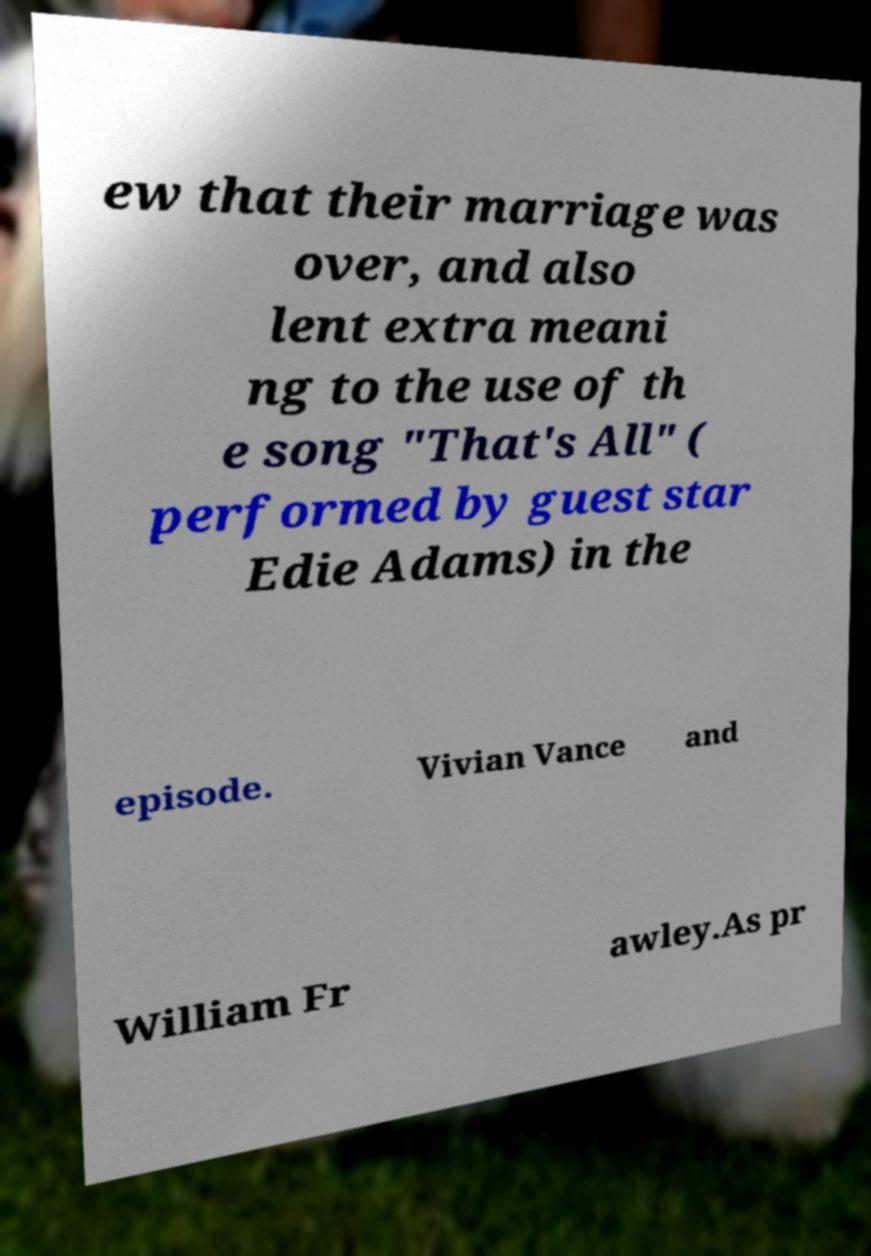Could you assist in decoding the text presented in this image and type it out clearly? ew that their marriage was over, and also lent extra meani ng to the use of th e song "That's All" ( performed by guest star Edie Adams) in the episode. Vivian Vance and William Fr awley.As pr 